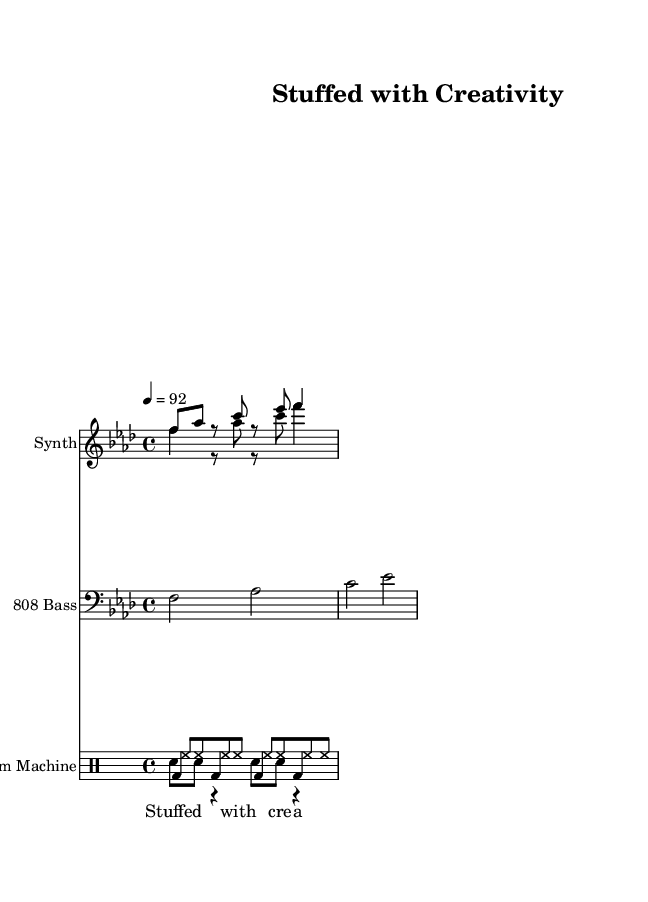What is the key signature of this music? The key signature is F minor, which has four flats (B♭, E♭, A♭, and D♭). This can be identified at the beginning of the staff, where the flats are noted.
Answer: F minor What is the time signature of this music? The time signature is 4/4, indicated at the beginning of the piece, which means there are four beats per measure and the quarter note gets the beat.
Answer: 4/4 What is the tempo marking of this music? The tempo marking is 92 beats per minute, specified at the beginning with “4 = 92”, indicating the speed at which the piece should be played.
Answer: 92 How many different instrument parts are there in this sheet music? There are three different instrument parts: Synth, 808 Bass, and Drum Machine. This can be determined by observing the distinct staves for each instrument.
Answer: Three What is the rhythmic pattern of the bassline? The bassline consists of four half notes: F, A♭, C, and E♭. This can be inferred from the bassline section that has only one note in each measure for a duration of two beats.
Answer: Four half notes What kind of sound is most prominent in this rap sheet music? The most prominent sound is produced by the Drum Machine. The drum section in the score shows a consistent pattern of bass and snare that is crucial for hardcore rap.
Answer: Drum Machine What is the primary theme conveyed by the lyrics? The primary theme conveyed by the lyrics is creativity, as shown in the text “Stuffed with creativity” placed under the chorus hook indicating the focus on artistic expression.
Answer: Creativity 